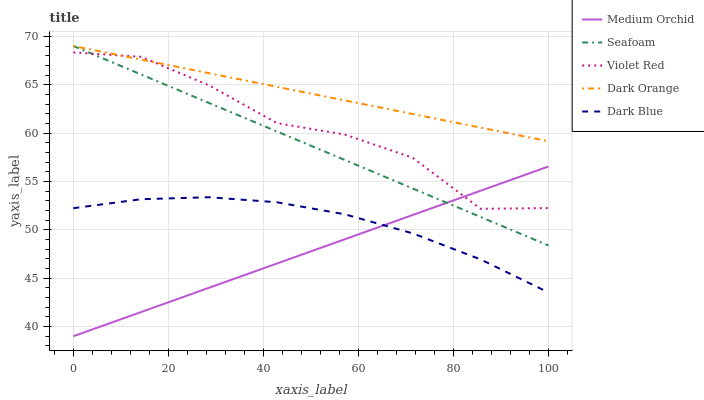Does Medium Orchid have the minimum area under the curve?
Answer yes or no. Yes. Does Dark Orange have the maximum area under the curve?
Answer yes or no. Yes. Does Violet Red have the minimum area under the curve?
Answer yes or no. No. Does Violet Red have the maximum area under the curve?
Answer yes or no. No. Is Medium Orchid the smoothest?
Answer yes or no. Yes. Is Violet Red the roughest?
Answer yes or no. Yes. Is Violet Red the smoothest?
Answer yes or no. No. Is Medium Orchid the roughest?
Answer yes or no. No. Does Medium Orchid have the lowest value?
Answer yes or no. Yes. Does Violet Red have the lowest value?
Answer yes or no. No. Does Seafoam have the highest value?
Answer yes or no. Yes. Does Violet Red have the highest value?
Answer yes or no. No. Is Dark Blue less than Seafoam?
Answer yes or no. Yes. Is Violet Red greater than Dark Blue?
Answer yes or no. Yes. Does Dark Orange intersect Violet Red?
Answer yes or no. Yes. Is Dark Orange less than Violet Red?
Answer yes or no. No. Is Dark Orange greater than Violet Red?
Answer yes or no. No. Does Dark Blue intersect Seafoam?
Answer yes or no. No. 